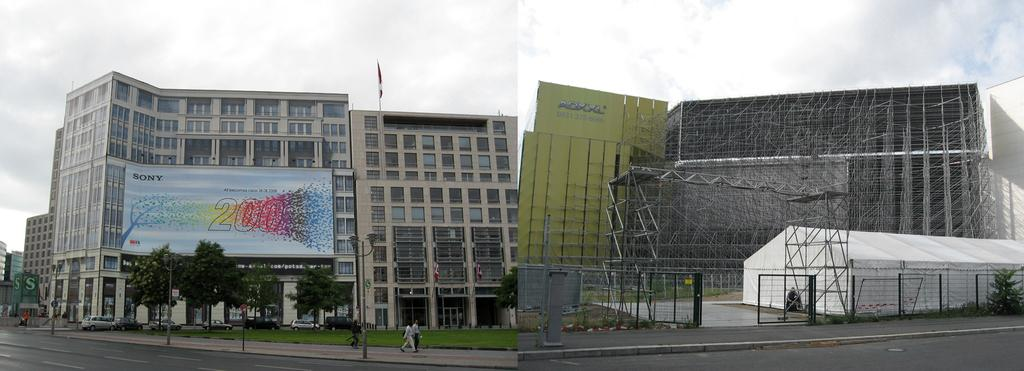What are the people in the image doing? The people in the image are walking. What can be seen on the ground in the image? There is a road in the image. What type of natural elements are present in the image? There are trees in the image. What type of man-made structures can be seen in the image? There are buildings in the image. Can you describe the flag in the image? There is a flag on a building in the image. What is visible in the sky in the image? The sky is visible and has clouds in the image. What type of work are the people doing at night in the image? The image does not depict any work being done, nor does it show a nighttime setting. 